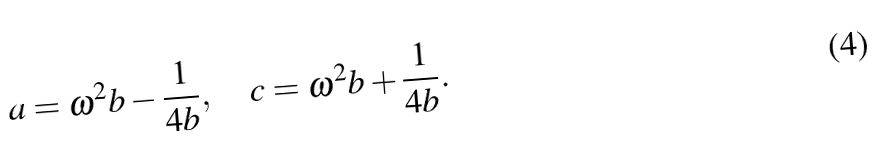<formula> <loc_0><loc_0><loc_500><loc_500>a = \omega ^ { 2 } b - \frac { 1 } { 4 b } , \quad c = \omega ^ { 2 } b + \frac { 1 } { 4 b } .</formula> 